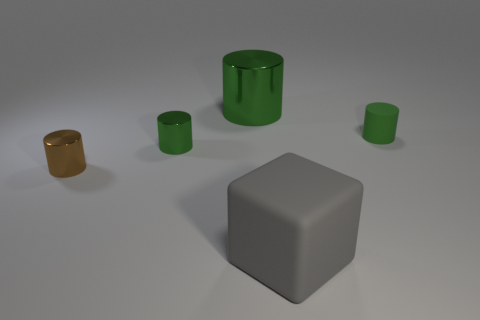The other metal object that is the same color as the big metallic object is what size?
Offer a terse response. Small. Is there anything else of the same color as the block?
Ensure brevity in your answer.  No. There is a metal cylinder behind the small metal cylinder that is behind the brown metallic cylinder; what color is it?
Your answer should be compact. Green. What material is the big gray thing to the right of the small green object in front of the tiny object that is on the right side of the big gray object?
Your answer should be compact. Rubber. What number of other green cylinders have the same size as the green rubber cylinder?
Make the answer very short. 1. What is the material of the thing that is both behind the gray object and on the right side of the big metallic cylinder?
Your answer should be compact. Rubber. There is a brown object; how many tiny metal cylinders are on the right side of it?
Keep it short and to the point. 1. Is the shape of the tiny brown shiny thing the same as the big thing on the left side of the gray cube?
Your answer should be compact. Yes. Is there another thing that has the same shape as the green rubber object?
Provide a short and direct response. Yes. The matte object in front of the green cylinder to the right of the large cylinder is what shape?
Provide a short and direct response. Cube. 